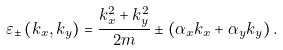Convert formula to latex. <formula><loc_0><loc_0><loc_500><loc_500>\varepsilon _ { \pm } \left ( k _ { x } , k _ { y } \right ) = \frac { k _ { x } ^ { 2 } + k _ { y } ^ { 2 } } { 2 m } \pm \left ( \alpha _ { x } k _ { x } + \alpha _ { y } k _ { y } \right ) .</formula> 